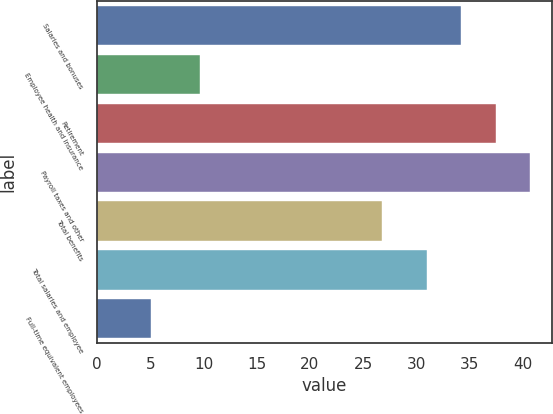Convert chart. <chart><loc_0><loc_0><loc_500><loc_500><bar_chart><fcel>Salaries and bonuses<fcel>Employee health and insurance<fcel>Retirement<fcel>Payroll taxes and other<fcel>Total benefits<fcel>Total salaries and employee<fcel>Full-time equivalent employees<nl><fcel>34.24<fcel>9.7<fcel>37.48<fcel>40.72<fcel>26.8<fcel>31<fcel>5.1<nl></chart> 